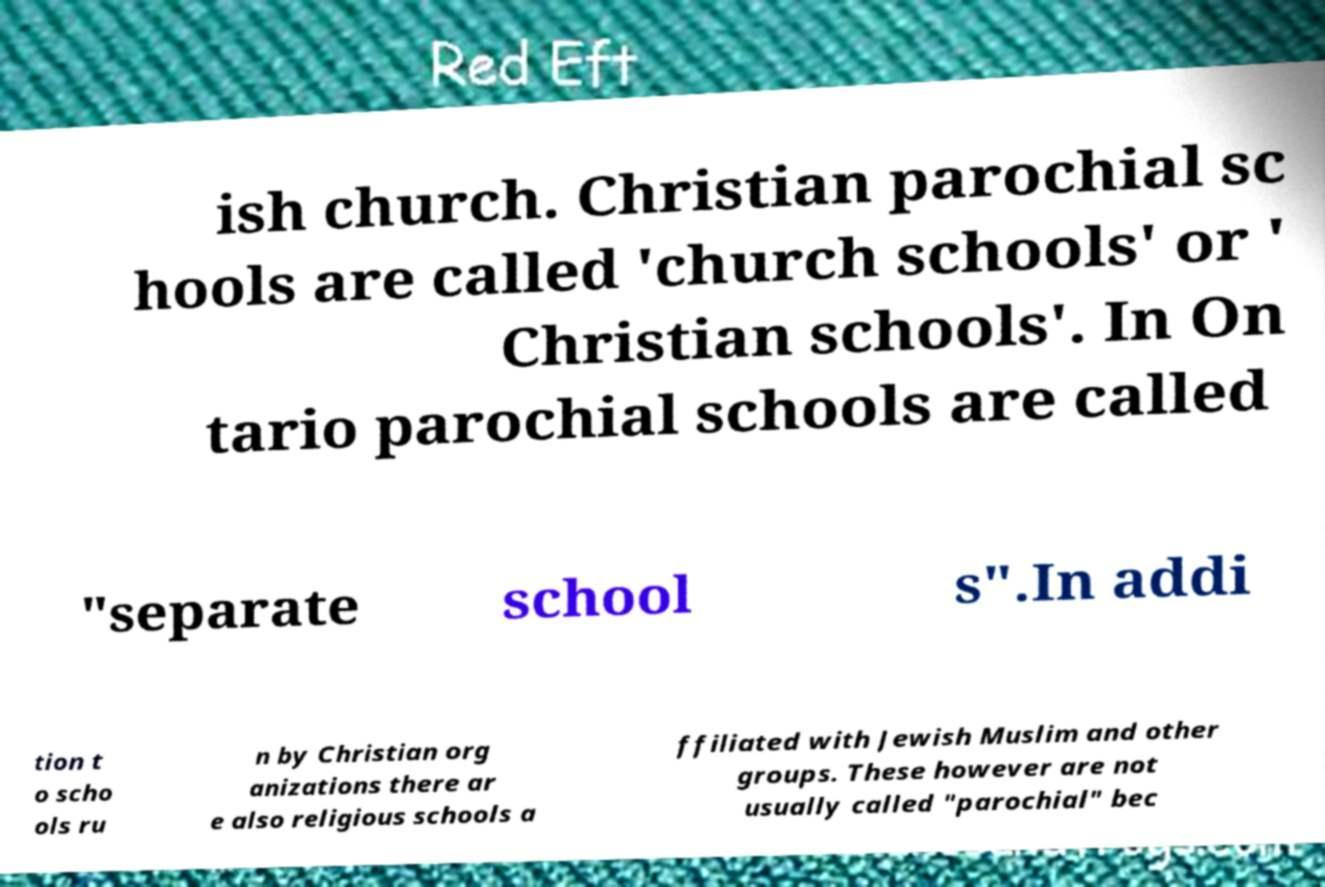Can you accurately transcribe the text from the provided image for me? ish church. Christian parochial sc hools are called 'church schools' or ' Christian schools'. In On tario parochial schools are called "separate school s".In addi tion t o scho ols ru n by Christian org anizations there ar e also religious schools a ffiliated with Jewish Muslim and other groups. These however are not usually called "parochial" bec 